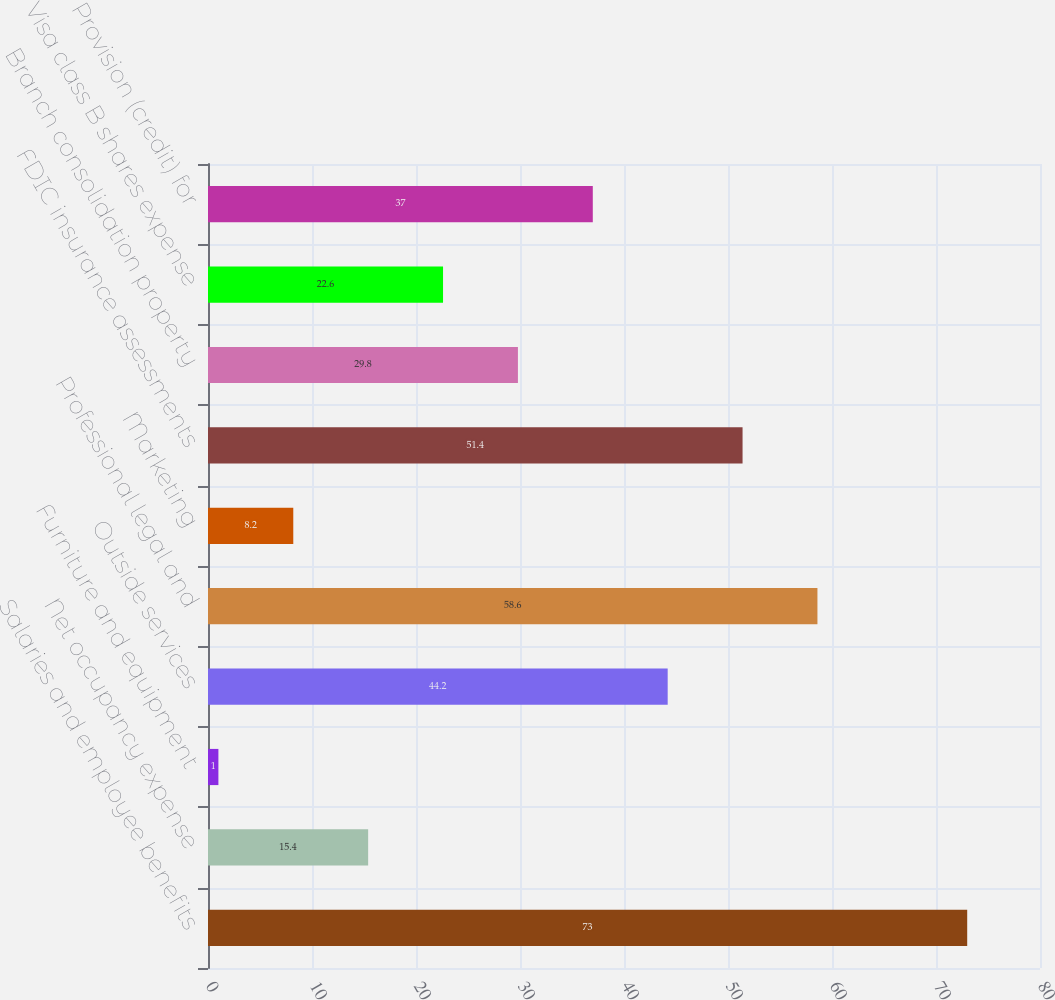Convert chart to OTSL. <chart><loc_0><loc_0><loc_500><loc_500><bar_chart><fcel>Salaries and employee benefits<fcel>Net occupancy expense<fcel>Furniture and equipment<fcel>Outside services<fcel>Professional legal and<fcel>Marketing<fcel>FDIC insurance assessments<fcel>Branch consolidation property<fcel>Visa class B shares expense<fcel>Provision (credit) for<nl><fcel>73<fcel>15.4<fcel>1<fcel>44.2<fcel>58.6<fcel>8.2<fcel>51.4<fcel>29.8<fcel>22.6<fcel>37<nl></chart> 